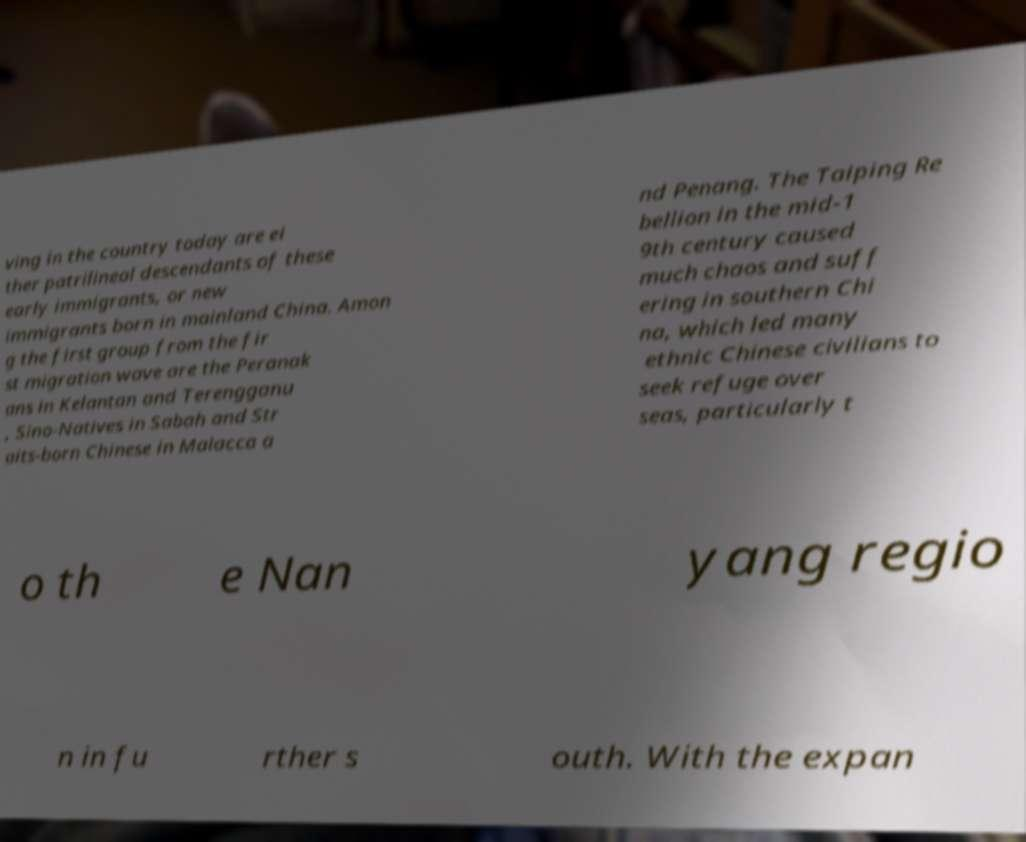Could you extract and type out the text from this image? ving in the country today are ei ther patrilineal descendants of these early immigrants, or new immigrants born in mainland China. Amon g the first group from the fir st migration wave are the Peranak ans in Kelantan and Terengganu , Sino-Natives in Sabah and Str aits-born Chinese in Malacca a nd Penang. The Taiping Re bellion in the mid-1 9th century caused much chaos and suff ering in southern Chi na, which led many ethnic Chinese civilians to seek refuge over seas, particularly t o th e Nan yang regio n in fu rther s outh. With the expan 